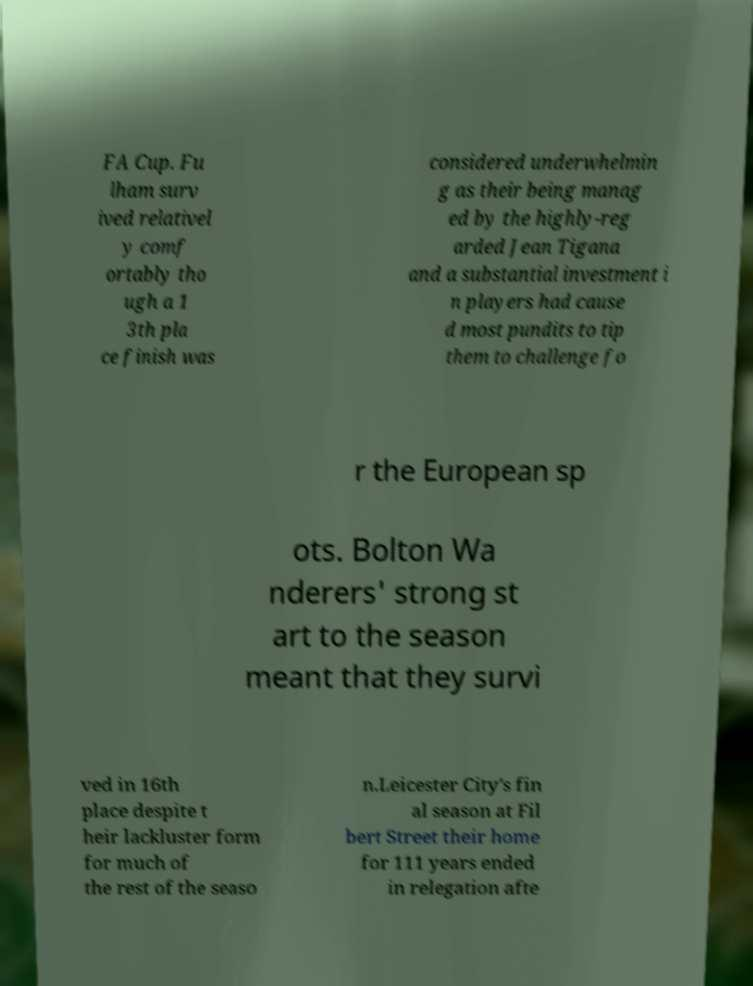I need the written content from this picture converted into text. Can you do that? FA Cup. Fu lham surv ived relativel y comf ortably tho ugh a 1 3th pla ce finish was considered underwhelmin g as their being manag ed by the highly-reg arded Jean Tigana and a substantial investment i n players had cause d most pundits to tip them to challenge fo r the European sp ots. Bolton Wa nderers' strong st art to the season meant that they survi ved in 16th place despite t heir lackluster form for much of the rest of the seaso n.Leicester City's fin al season at Fil bert Street their home for 111 years ended in relegation afte 